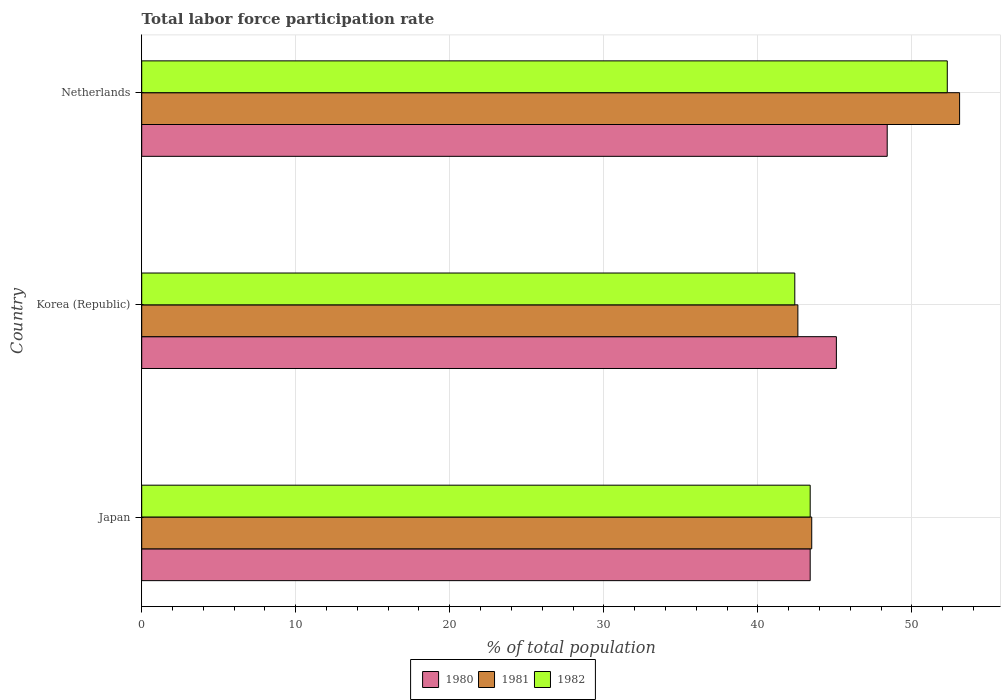How many different coloured bars are there?
Your answer should be very brief. 3. How many groups of bars are there?
Keep it short and to the point. 3. How many bars are there on the 2nd tick from the top?
Ensure brevity in your answer.  3. How many bars are there on the 3rd tick from the bottom?
Offer a terse response. 3. What is the label of the 1st group of bars from the top?
Provide a succinct answer. Netherlands. What is the total labor force participation rate in 1981 in Korea (Republic)?
Provide a short and direct response. 42.6. Across all countries, what is the maximum total labor force participation rate in 1982?
Keep it short and to the point. 52.3. Across all countries, what is the minimum total labor force participation rate in 1981?
Your answer should be very brief. 42.6. In which country was the total labor force participation rate in 1981 maximum?
Ensure brevity in your answer.  Netherlands. What is the total total labor force participation rate in 1980 in the graph?
Your answer should be very brief. 136.9. What is the difference between the total labor force participation rate in 1980 in Korea (Republic) and that in Netherlands?
Provide a short and direct response. -3.3. What is the difference between the total labor force participation rate in 1982 in Netherlands and the total labor force participation rate in 1980 in Korea (Republic)?
Provide a succinct answer. 7.2. What is the average total labor force participation rate in 1980 per country?
Offer a terse response. 45.63. What is the difference between the total labor force participation rate in 1981 and total labor force participation rate in 1980 in Netherlands?
Give a very brief answer. 4.7. What is the ratio of the total labor force participation rate in 1980 in Japan to that in Netherlands?
Your answer should be very brief. 0.9. What is the difference between the highest and the second highest total labor force participation rate in 1981?
Offer a very short reply. 9.6. What does the 3rd bar from the top in Netherlands represents?
Offer a terse response. 1980. Is it the case that in every country, the sum of the total labor force participation rate in 1982 and total labor force participation rate in 1980 is greater than the total labor force participation rate in 1981?
Provide a short and direct response. Yes. How many countries are there in the graph?
Your answer should be very brief. 3. What is the difference between two consecutive major ticks on the X-axis?
Provide a short and direct response. 10. Does the graph contain any zero values?
Your response must be concise. No. Does the graph contain grids?
Your answer should be very brief. Yes. Where does the legend appear in the graph?
Your response must be concise. Bottom center. How many legend labels are there?
Ensure brevity in your answer.  3. How are the legend labels stacked?
Provide a short and direct response. Horizontal. What is the title of the graph?
Ensure brevity in your answer.  Total labor force participation rate. Does "1970" appear as one of the legend labels in the graph?
Provide a short and direct response. No. What is the label or title of the X-axis?
Offer a terse response. % of total population. What is the % of total population in 1980 in Japan?
Offer a very short reply. 43.4. What is the % of total population of 1981 in Japan?
Offer a terse response. 43.5. What is the % of total population of 1982 in Japan?
Make the answer very short. 43.4. What is the % of total population of 1980 in Korea (Republic)?
Give a very brief answer. 45.1. What is the % of total population of 1981 in Korea (Republic)?
Your response must be concise. 42.6. What is the % of total population in 1982 in Korea (Republic)?
Your response must be concise. 42.4. What is the % of total population in 1980 in Netherlands?
Make the answer very short. 48.4. What is the % of total population of 1981 in Netherlands?
Your answer should be very brief. 53.1. What is the % of total population of 1982 in Netherlands?
Make the answer very short. 52.3. Across all countries, what is the maximum % of total population of 1980?
Ensure brevity in your answer.  48.4. Across all countries, what is the maximum % of total population of 1981?
Offer a terse response. 53.1. Across all countries, what is the maximum % of total population of 1982?
Make the answer very short. 52.3. Across all countries, what is the minimum % of total population of 1980?
Offer a very short reply. 43.4. Across all countries, what is the minimum % of total population of 1981?
Your answer should be very brief. 42.6. Across all countries, what is the minimum % of total population in 1982?
Provide a short and direct response. 42.4. What is the total % of total population in 1980 in the graph?
Give a very brief answer. 136.9. What is the total % of total population of 1981 in the graph?
Provide a succinct answer. 139.2. What is the total % of total population of 1982 in the graph?
Make the answer very short. 138.1. What is the difference between the % of total population of 1981 in Japan and that in Korea (Republic)?
Your answer should be very brief. 0.9. What is the difference between the % of total population in 1980 in Japan and that in Netherlands?
Your response must be concise. -5. What is the difference between the % of total population of 1981 in Japan and that in Netherlands?
Make the answer very short. -9.6. What is the difference between the % of total population in 1980 in Korea (Republic) and that in Netherlands?
Provide a succinct answer. -3.3. What is the difference between the % of total population in 1982 in Korea (Republic) and that in Netherlands?
Your response must be concise. -9.9. What is the difference between the % of total population in 1981 in Japan and the % of total population in 1982 in Korea (Republic)?
Give a very brief answer. 1.1. What is the difference between the % of total population of 1980 in Japan and the % of total population of 1981 in Netherlands?
Your answer should be compact. -9.7. What is the difference between the % of total population in 1980 in Korea (Republic) and the % of total population in 1981 in Netherlands?
Provide a succinct answer. -8. What is the difference between the % of total population of 1980 in Korea (Republic) and the % of total population of 1982 in Netherlands?
Provide a short and direct response. -7.2. What is the difference between the % of total population of 1981 in Korea (Republic) and the % of total population of 1982 in Netherlands?
Offer a very short reply. -9.7. What is the average % of total population of 1980 per country?
Your answer should be compact. 45.63. What is the average % of total population of 1981 per country?
Ensure brevity in your answer.  46.4. What is the average % of total population in 1982 per country?
Provide a succinct answer. 46.03. What is the difference between the % of total population of 1981 and % of total population of 1982 in Japan?
Provide a short and direct response. 0.1. What is the difference between the % of total population in 1980 and % of total population in 1981 in Korea (Republic)?
Provide a short and direct response. 2.5. What is the difference between the % of total population in 1980 and % of total population in 1982 in Netherlands?
Offer a very short reply. -3.9. What is the ratio of the % of total population of 1980 in Japan to that in Korea (Republic)?
Your answer should be very brief. 0.96. What is the ratio of the % of total population of 1981 in Japan to that in Korea (Republic)?
Keep it short and to the point. 1.02. What is the ratio of the % of total population in 1982 in Japan to that in Korea (Republic)?
Keep it short and to the point. 1.02. What is the ratio of the % of total population in 1980 in Japan to that in Netherlands?
Give a very brief answer. 0.9. What is the ratio of the % of total population in 1981 in Japan to that in Netherlands?
Your response must be concise. 0.82. What is the ratio of the % of total population in 1982 in Japan to that in Netherlands?
Provide a succinct answer. 0.83. What is the ratio of the % of total population in 1980 in Korea (Republic) to that in Netherlands?
Offer a very short reply. 0.93. What is the ratio of the % of total population of 1981 in Korea (Republic) to that in Netherlands?
Provide a short and direct response. 0.8. What is the ratio of the % of total population in 1982 in Korea (Republic) to that in Netherlands?
Offer a very short reply. 0.81. What is the difference between the highest and the second highest % of total population of 1980?
Your answer should be very brief. 3.3. What is the difference between the highest and the second highest % of total population of 1981?
Keep it short and to the point. 9.6. What is the difference between the highest and the second highest % of total population of 1982?
Provide a succinct answer. 8.9. What is the difference between the highest and the lowest % of total population in 1981?
Provide a short and direct response. 10.5. What is the difference between the highest and the lowest % of total population of 1982?
Offer a terse response. 9.9. 